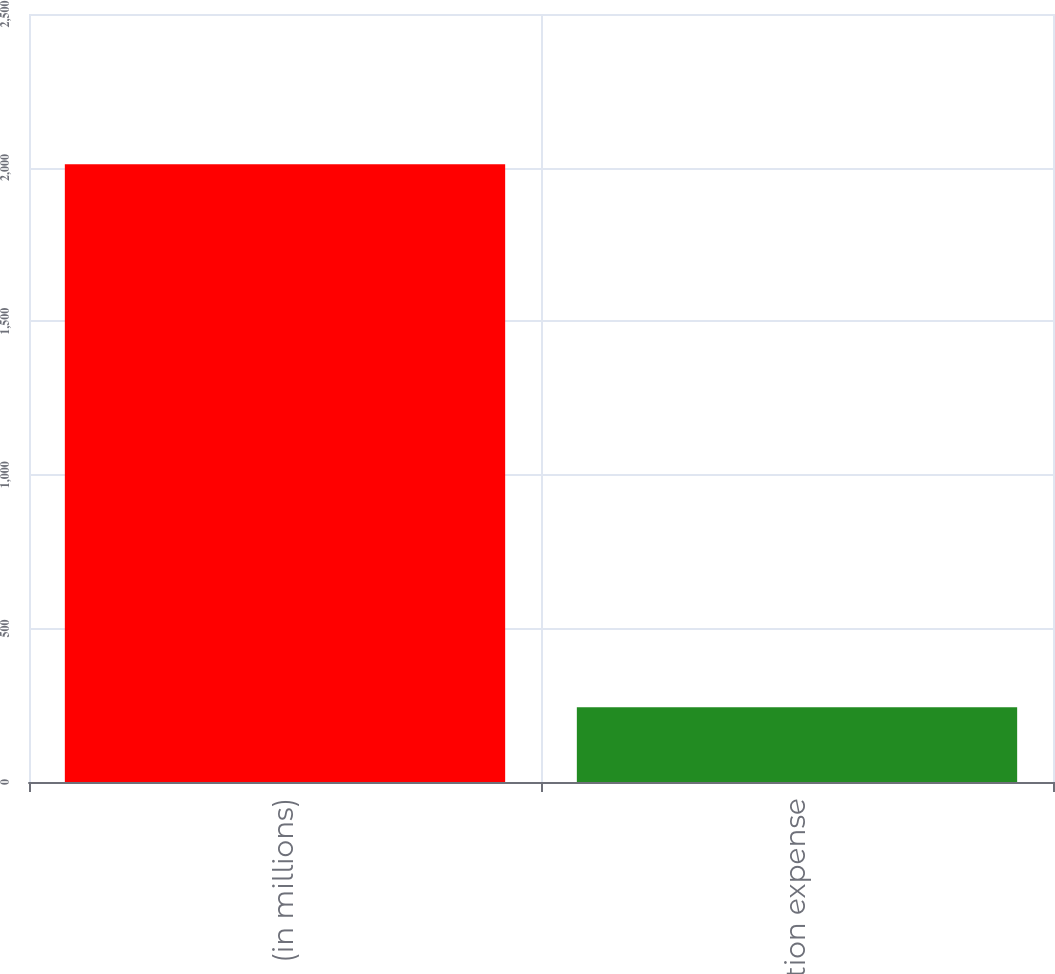<chart> <loc_0><loc_0><loc_500><loc_500><bar_chart><fcel>(in millions)<fcel>Depreciation expense<nl><fcel>2011<fcel>243.7<nl></chart> 